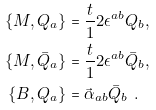Convert formula to latex. <formula><loc_0><loc_0><loc_500><loc_500>\{ M , Q _ { a } \} & = \frac { t } { 1 } 2 \epsilon ^ { a b } Q _ { b } , \\ \{ M , \bar { Q } _ { a } \} & = \frac { t } { 1 } 2 \epsilon ^ { a b } \bar { Q } _ { b } , \\ \{ { B } , Q _ { a } \} & = \vec { \alpha } _ { a b } \bar { Q } _ { b } \ .</formula> 